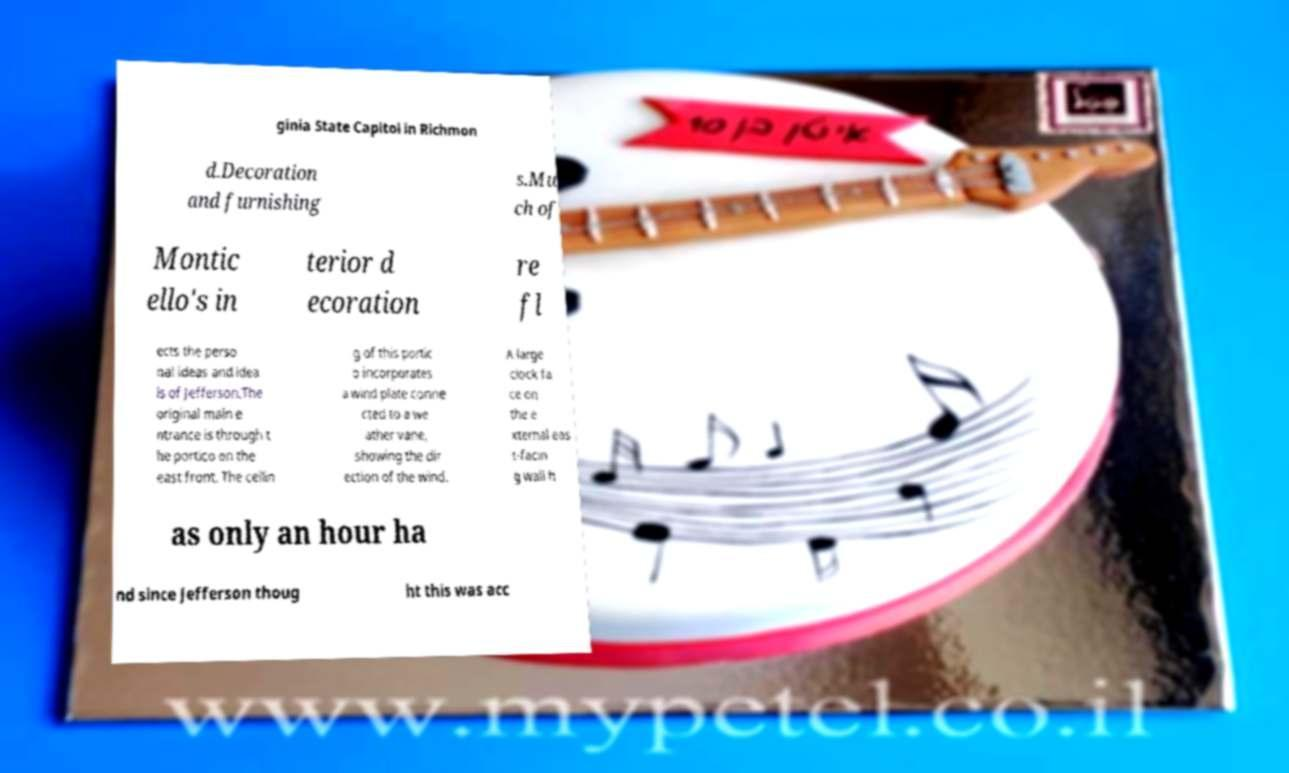I need the written content from this picture converted into text. Can you do that? ginia State Capitol in Richmon d.Decoration and furnishing s.Mu ch of Montic ello's in terior d ecoration re fl ects the perso nal ideas and idea ls of Jefferson.The original main e ntrance is through t he portico on the east front. The ceilin g of this portic o incorporates a wind plate conne cted to a we ather vane, showing the dir ection of the wind. A large clock fa ce on the e xternal eas t-facin g wall h as only an hour ha nd since Jefferson thoug ht this was acc 